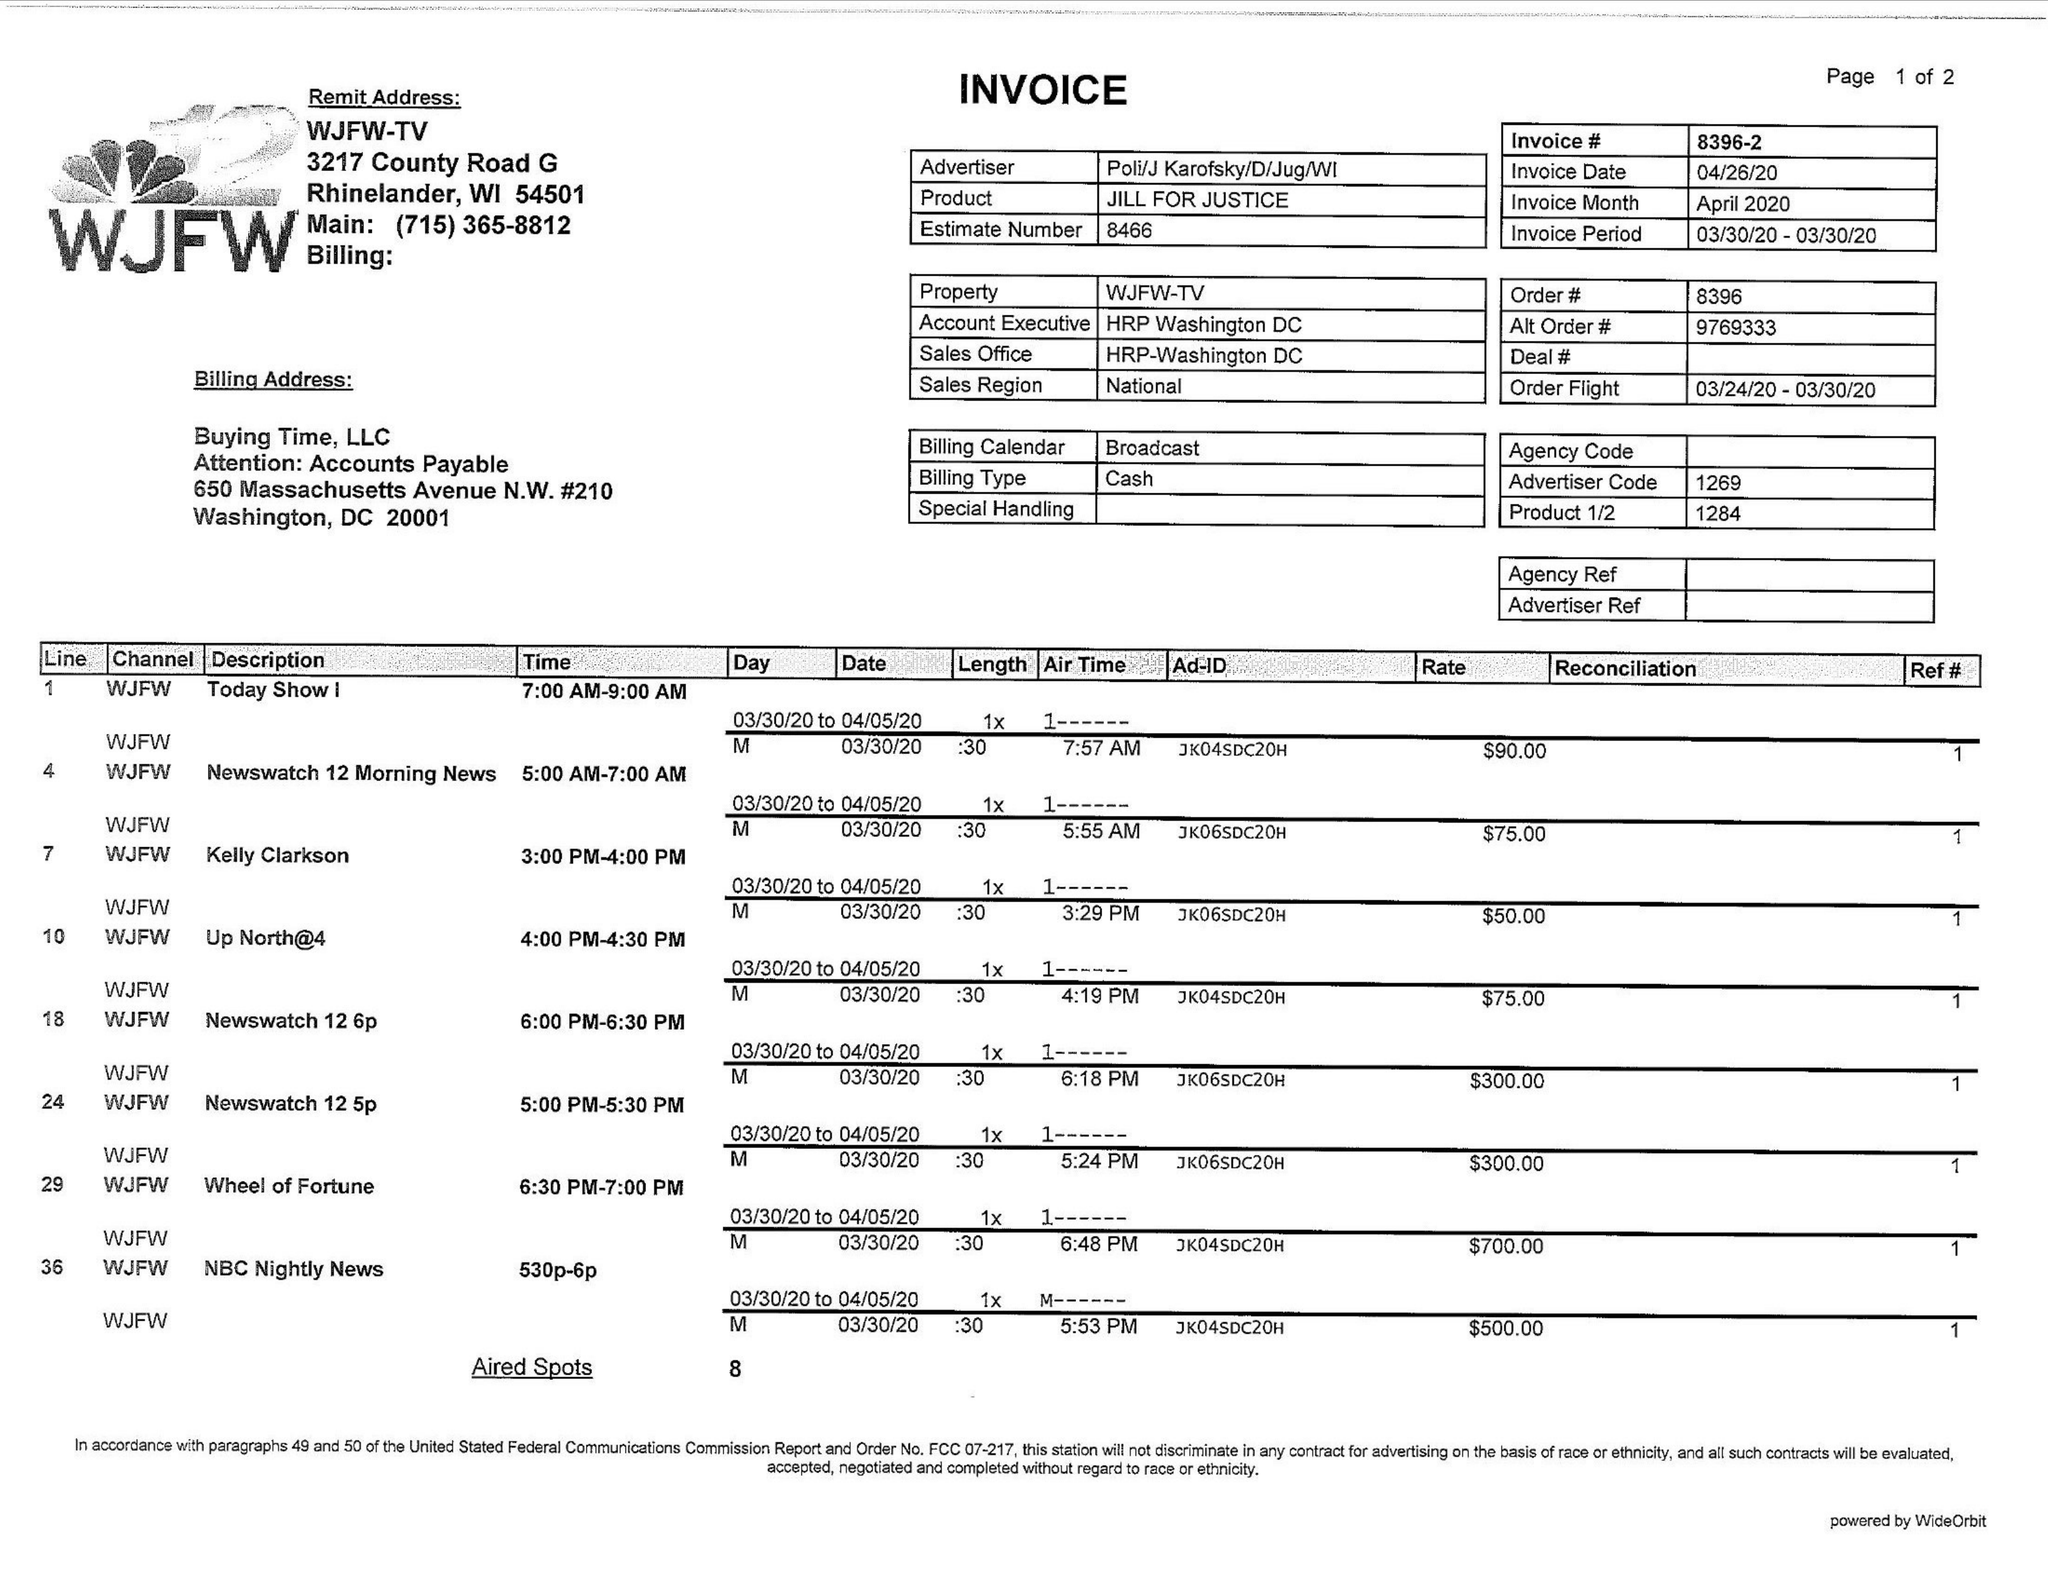What is the value for the contract_num?
Answer the question using a single word or phrase. 8396 